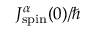Convert formula to latex. <formula><loc_0><loc_0><loc_500><loc_500>J _ { s p i n } ^ { \alpha } ( 0 ) / \hbar</formula> 